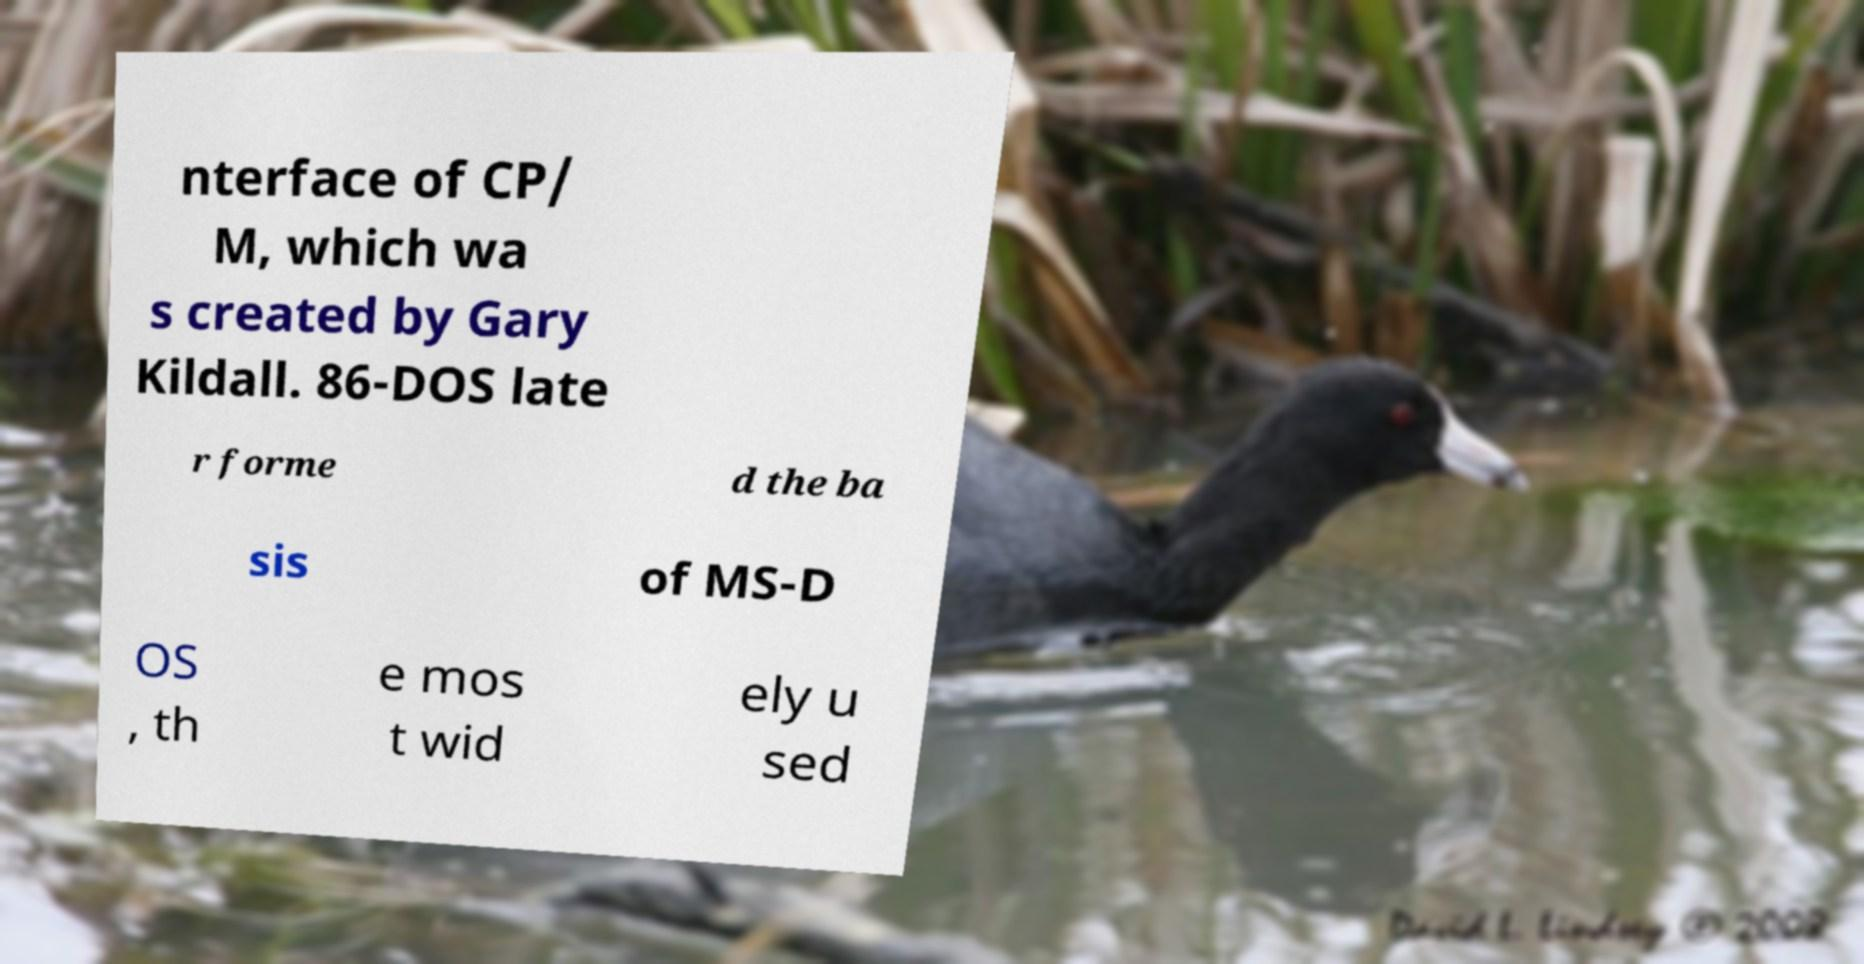Please read and relay the text visible in this image. What does it say? nterface of CP/ M, which wa s created by Gary Kildall. 86-DOS late r forme d the ba sis of MS-D OS , th e mos t wid ely u sed 